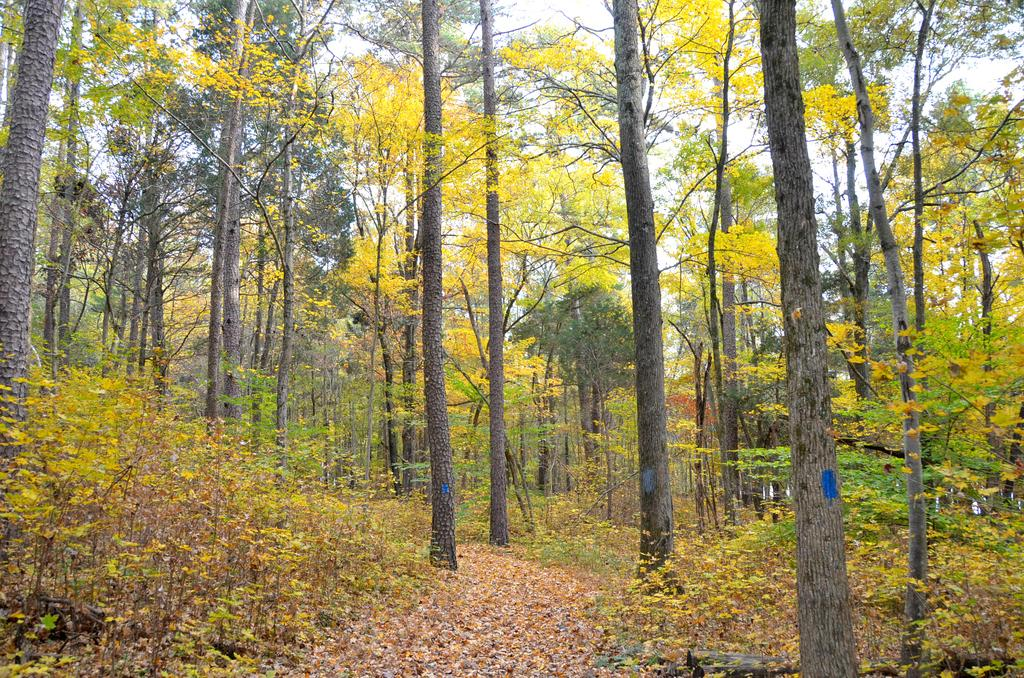What type of vegetation can be seen in the image? There are trees and plants in the image. What is the condition of the leaves on the trees and plants? Dried leaves are present in the image. What can be seen through the trees in the image? The sky is visible through the trees in the image. What type of plastic is covering the train in the image? There is no train present in the image; it only features trees, plants, and dried leaves. 